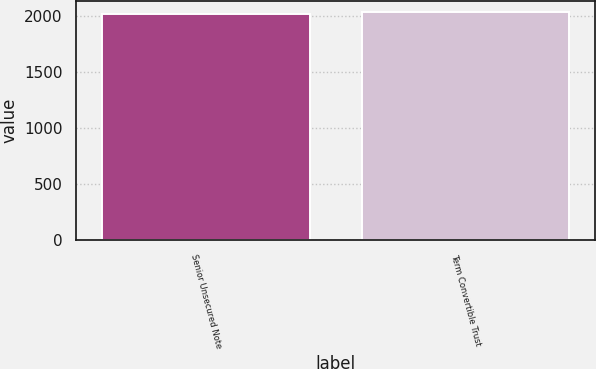Convert chart. <chart><loc_0><loc_0><loc_500><loc_500><bar_chart><fcel>Senior Unsecured Note<fcel>Term Convertible Trust<nl><fcel>2014<fcel>2029<nl></chart> 